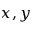<formula> <loc_0><loc_0><loc_500><loc_500>x , y</formula> 